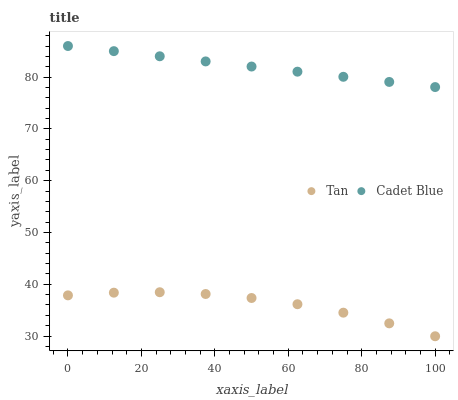Does Tan have the minimum area under the curve?
Answer yes or no. Yes. Does Cadet Blue have the maximum area under the curve?
Answer yes or no. Yes. Does Cadet Blue have the minimum area under the curve?
Answer yes or no. No. Is Cadet Blue the smoothest?
Answer yes or no. Yes. Is Tan the roughest?
Answer yes or no. Yes. Is Cadet Blue the roughest?
Answer yes or no. No. Does Tan have the lowest value?
Answer yes or no. Yes. Does Cadet Blue have the lowest value?
Answer yes or no. No. Does Cadet Blue have the highest value?
Answer yes or no. Yes. Is Tan less than Cadet Blue?
Answer yes or no. Yes. Is Cadet Blue greater than Tan?
Answer yes or no. Yes. Does Tan intersect Cadet Blue?
Answer yes or no. No. 